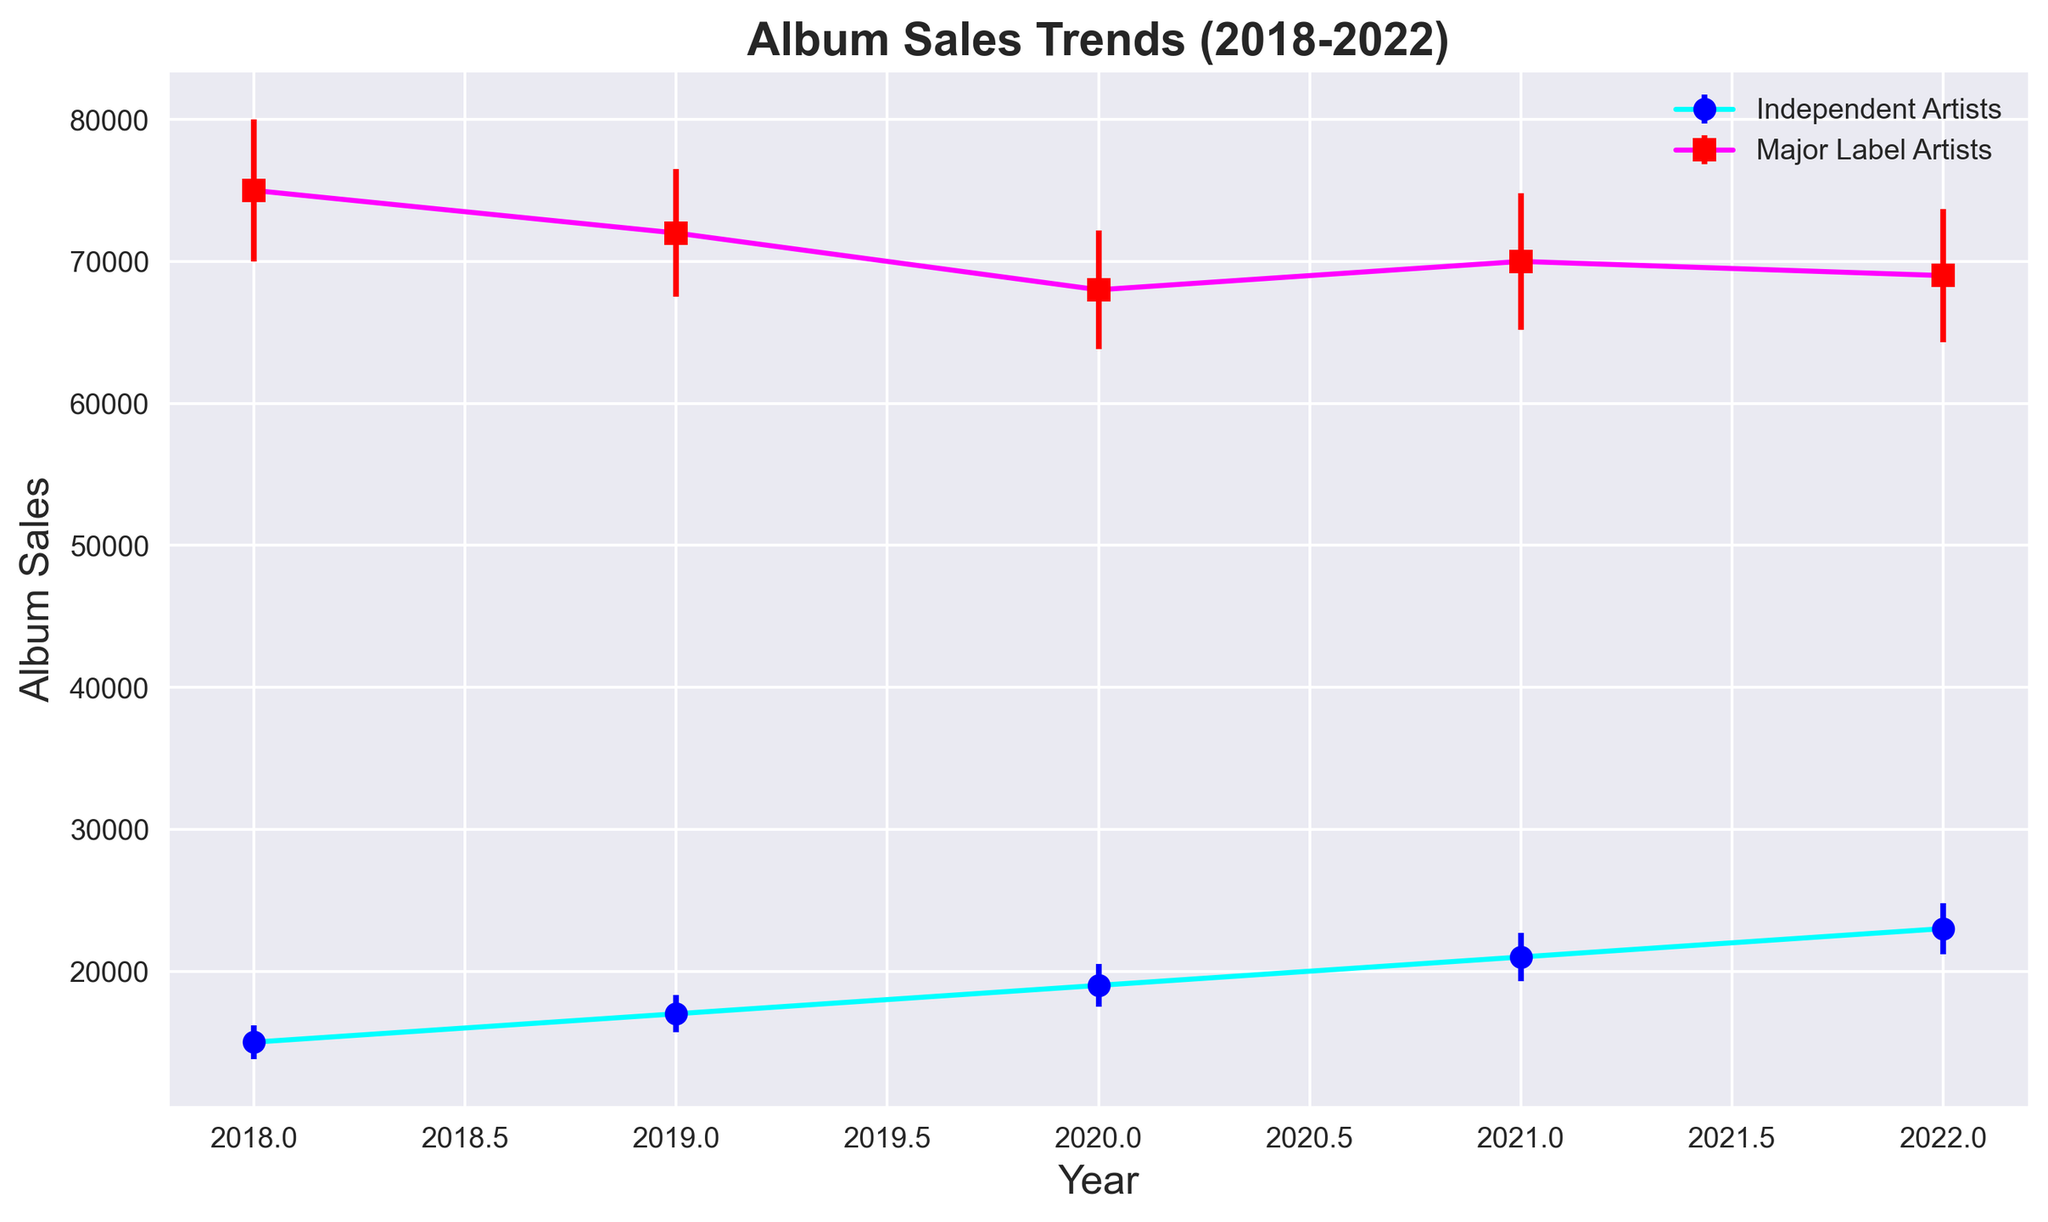What's the trend in album sales for independent artists from 2018 to 2022? The album sales for independent artists show a continuous upward trend from 15,000 in 2018 to 23,000 in 2022.
Answer: Continuous increase How do the errors in album sales for major label artists compare to those for independent artists over the years? The error bars for major label artists are larger than those for independent artists across all years, with major label errors ranging between 4,200-5,000 and independent artists' errors ranging between 1,200-1,800.
Answer: Major label errors are larger In which year did independent artists see the largest increase in album sales? Between 2020 and 2021, independent artists saw the largest year-over-year increase, from 19,000 to 21,000, which is an increase of 2,000.
Answer: 2021 Compare the album sales of major label artists in 2020 and 2022. Which year saw higher sales? In 2020, major label artists sold 68,000 albums, whereas in 2022, they sold 69,000. Thus, 2022 saw higher sales.
Answer: 2022 What's the combined album sales for both major label and independent artists in 2019? Combined album sales = 17,000 (independent) + 72,000 (major) = 89,000.
Answer: 89,000 Which artist group has a more consistent trend in album sales from 2018 to 2022? Independent artists have a more consistent upward trend in album sales, whereas major label artists show a fluctuating trend.
Answer: Independent artists What is the difference in album sales between major label artists in 2018 and major label artists in 2022? The difference in album sales between 2018 (75,000) and 2022 (69,000) is 75,000 - 69,000 = 6,000.
Answer: 6,000 Which year had the smallest error margin for independent artists? The smallest error margin for independent artists was in 2018 when it was 1,200.
Answer: 2018 How do the visualization colors for independent artists and major label artists help in differentiating the sales trends? The independent artists' data is represented by cyan and blue colors, while the major label artists' data is shown using magenta and red. This color differentiation helps easily distinguish between the two groups on the plot.
Answer: Different colors for each group If you add the errors of independent artists' sales in 2021 and 2022, what do you get? The error in 2021 is 1,700, and in 2022 it is 1,800. Adding them gives 1,700 + 1,800 = 3,500.
Answer: 3,500 